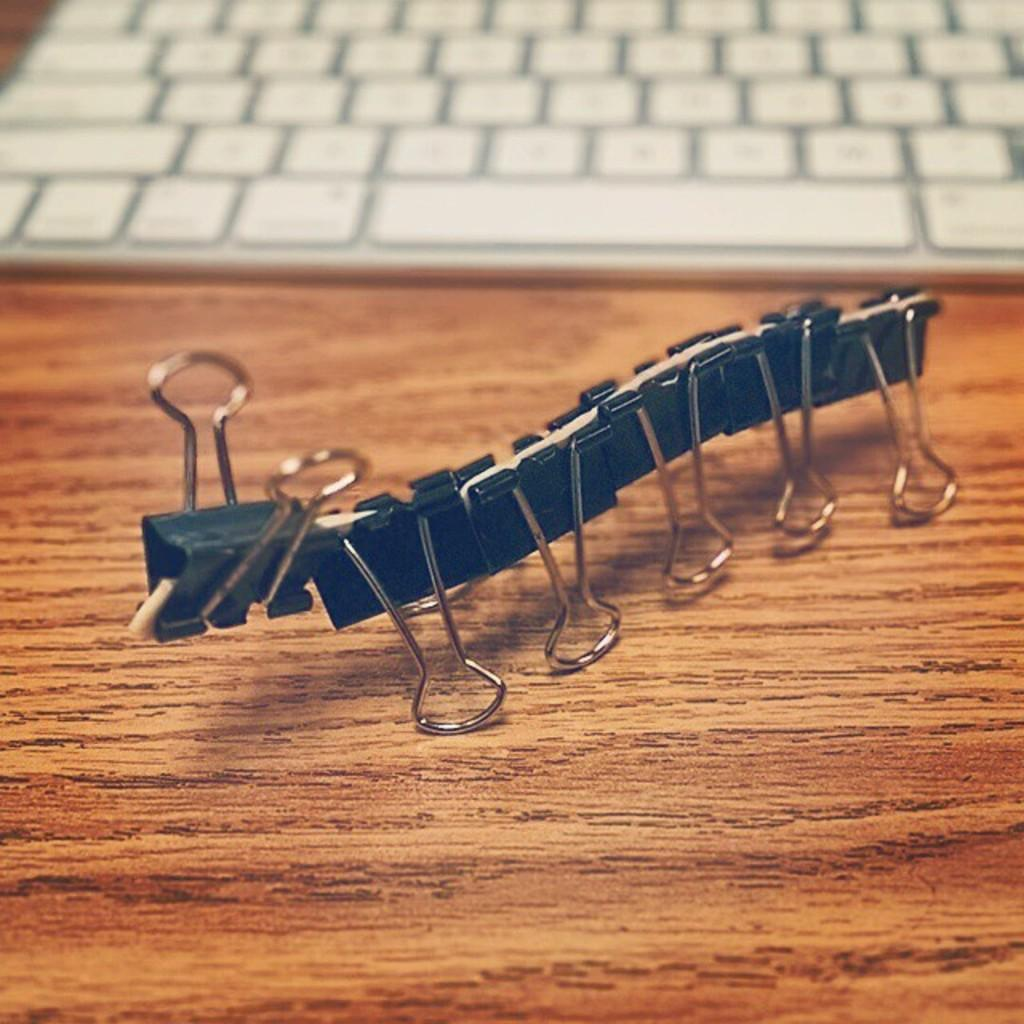What is the main object on the table in the image? There is a keyboard on the table in the image. What else can be seen on the table besides the keyboard? There are paper clips visible on the table in the image. Can you describe the location of the paper clips in relation to the keyboard? Both the keyboard and paper clips are on the table in the image. How many sheep can be seen grazing on the slope near the table in the image? There are no sheep or slopes present in the image; it only features a keyboard and paper clips on a table. 